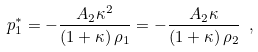Convert formula to latex. <formula><loc_0><loc_0><loc_500><loc_500>p _ { 1 } ^ { * } = - \frac { A _ { 2 } \kappa ^ { 2 } } { \left ( 1 + \kappa \right ) \rho _ { 1 } } = - \frac { A _ { 2 } \kappa } { \left ( 1 + \kappa \right ) \rho _ { 2 } } \ ,</formula> 